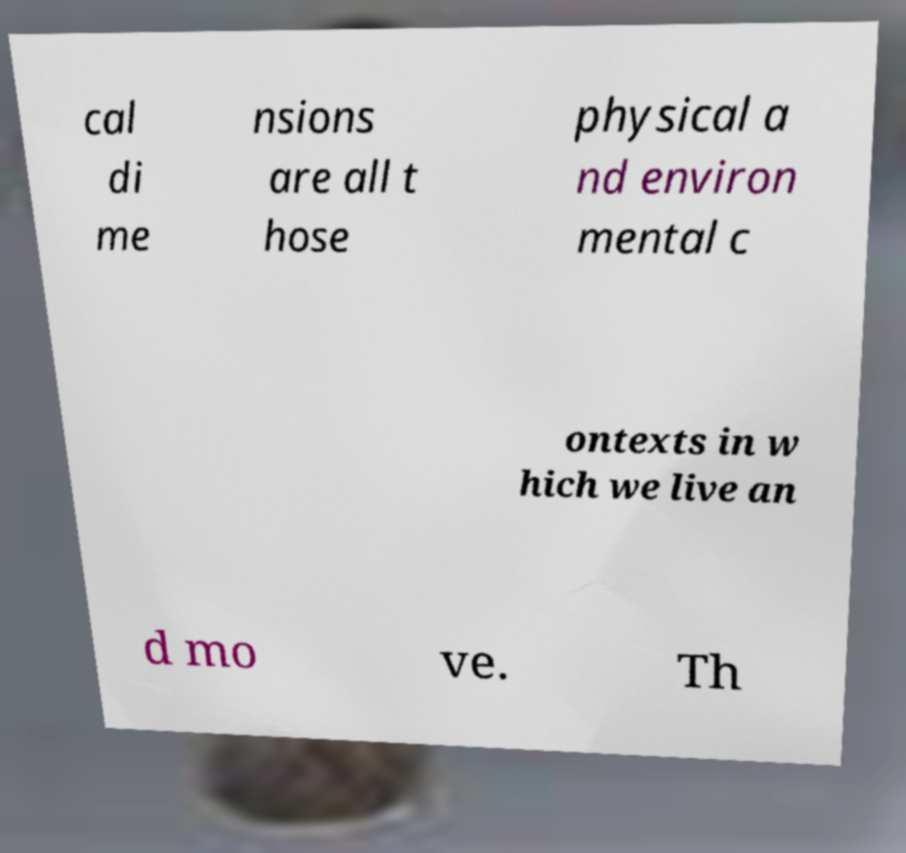For documentation purposes, I need the text within this image transcribed. Could you provide that? cal di me nsions are all t hose physical a nd environ mental c ontexts in w hich we live an d mo ve. Th 